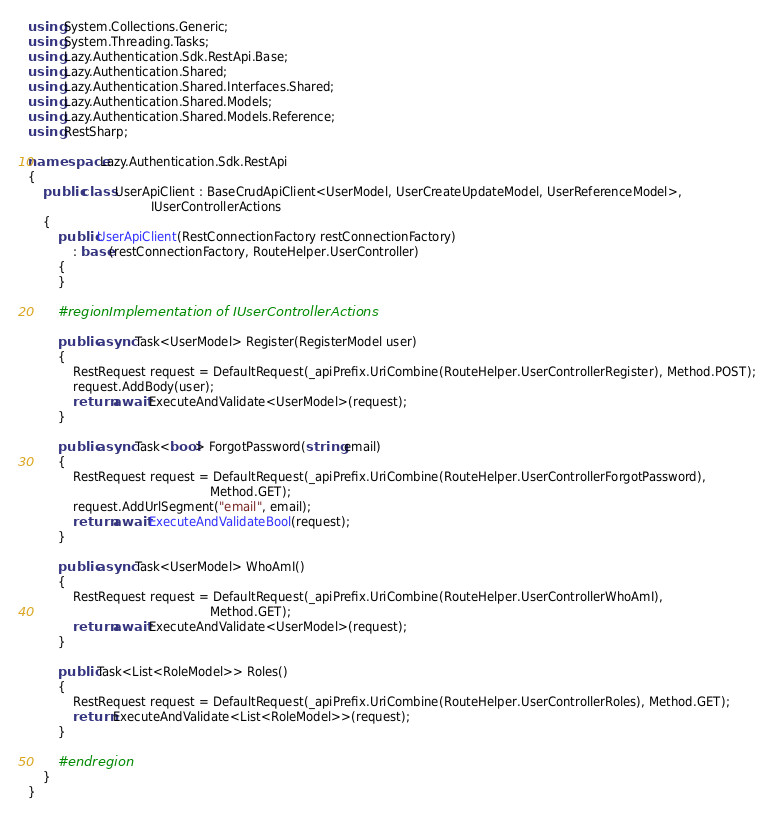<code> <loc_0><loc_0><loc_500><loc_500><_C#_>using System.Collections.Generic;
using System.Threading.Tasks;
using Lazy.Authentication.Sdk.RestApi.Base;
using Lazy.Authentication.Shared;
using Lazy.Authentication.Shared.Interfaces.Shared;
using Lazy.Authentication.Shared.Models;
using Lazy.Authentication.Shared.Models.Reference;
using RestSharp;

namespace Lazy.Authentication.Sdk.RestApi
{
    public class UserApiClient : BaseCrudApiClient<UserModel, UserCreateUpdateModel, UserReferenceModel>,
                                 IUserControllerActions
    {
        public UserApiClient(RestConnectionFactory restConnectionFactory)
            : base(restConnectionFactory, RouteHelper.UserController)
        {
        }

        #region Implementation of IUserControllerActions

        public async Task<UserModel> Register(RegisterModel user)
        {
            RestRequest request = DefaultRequest(_apiPrefix.UriCombine(RouteHelper.UserControllerRegister), Method.POST);
            request.AddBody(user);
            return await ExecuteAndValidate<UserModel>(request);
        }

        public async Task<bool> ForgotPassword(string email)
        {
            RestRequest request = DefaultRequest(_apiPrefix.UriCombine(RouteHelper.UserControllerForgotPassword),
                                                 Method.GET);
            request.AddUrlSegment("email", email);
            return await ExecuteAndValidateBool(request);
        }

        public async Task<UserModel> WhoAmI()
        {
            RestRequest request = DefaultRequest(_apiPrefix.UriCombine(RouteHelper.UserControllerWhoAmI),
                                                 Method.GET);
            return await ExecuteAndValidate<UserModel>(request);
        }

        public Task<List<RoleModel>> Roles()
        {
            RestRequest request = DefaultRequest(_apiPrefix.UriCombine(RouteHelper.UserControllerRoles), Method.GET);
            return ExecuteAndValidate<List<RoleModel>>(request);
        }

        #endregion
    }
}</code> 